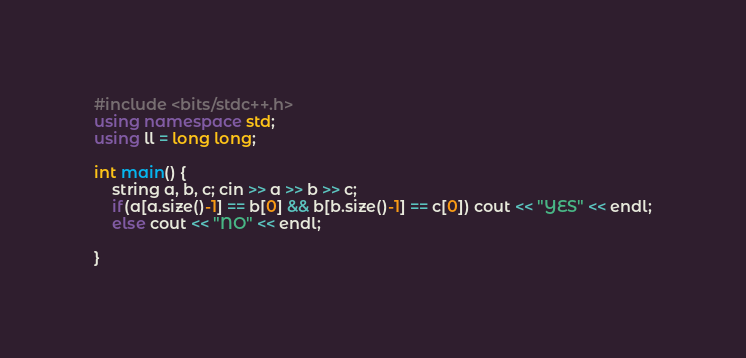<code> <loc_0><loc_0><loc_500><loc_500><_C++_>#include <bits/stdc++.h>
using namespace std;
using ll = long long;

int main() {
    string a, b, c; cin >> a >> b >> c;
    if(a[a.size()-1] == b[0] && b[b.size()-1] == c[0]) cout << "YES" << endl;
    else cout << "NO" << endl;
        
}</code> 